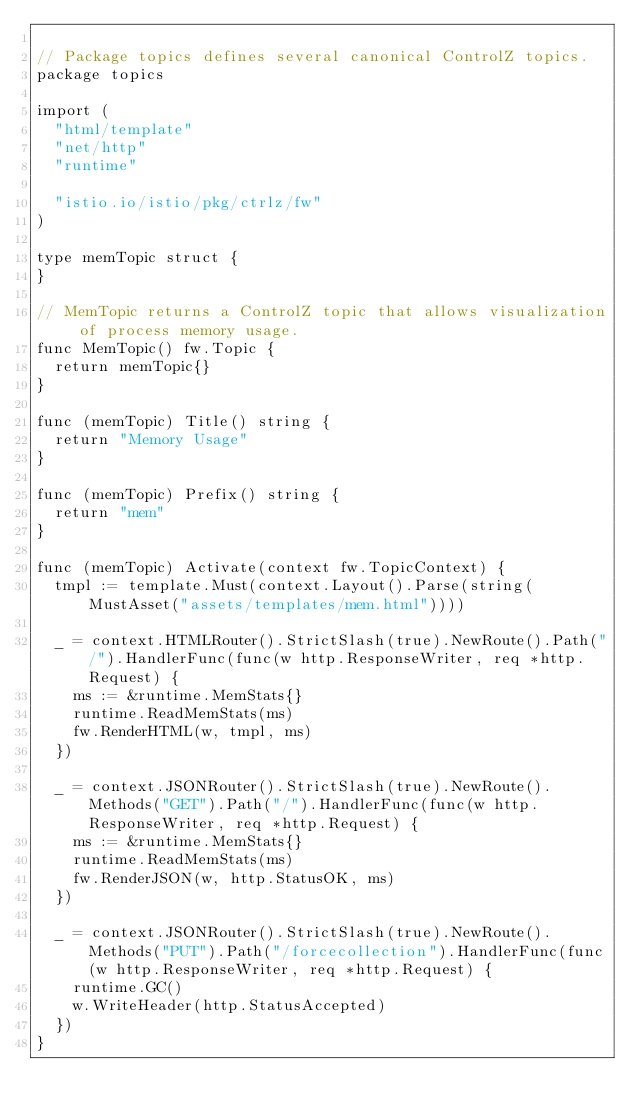<code> <loc_0><loc_0><loc_500><loc_500><_Go_>
// Package topics defines several canonical ControlZ topics.
package topics

import (
	"html/template"
	"net/http"
	"runtime"

	"istio.io/istio/pkg/ctrlz/fw"
)

type memTopic struct {
}

// MemTopic returns a ControlZ topic that allows visualization of process memory usage.
func MemTopic() fw.Topic {
	return memTopic{}
}

func (memTopic) Title() string {
	return "Memory Usage"
}

func (memTopic) Prefix() string {
	return "mem"
}

func (memTopic) Activate(context fw.TopicContext) {
	tmpl := template.Must(context.Layout().Parse(string(MustAsset("assets/templates/mem.html"))))

	_ = context.HTMLRouter().StrictSlash(true).NewRoute().Path("/").HandlerFunc(func(w http.ResponseWriter, req *http.Request) {
		ms := &runtime.MemStats{}
		runtime.ReadMemStats(ms)
		fw.RenderHTML(w, tmpl, ms)
	})

	_ = context.JSONRouter().StrictSlash(true).NewRoute().Methods("GET").Path("/").HandlerFunc(func(w http.ResponseWriter, req *http.Request) {
		ms := &runtime.MemStats{}
		runtime.ReadMemStats(ms)
		fw.RenderJSON(w, http.StatusOK, ms)
	})

	_ = context.JSONRouter().StrictSlash(true).NewRoute().Methods("PUT").Path("/forcecollection").HandlerFunc(func(w http.ResponseWriter, req *http.Request) {
		runtime.GC()
		w.WriteHeader(http.StatusAccepted)
	})
}
</code> 